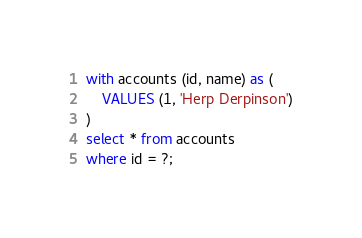Convert code to text. <code><loc_0><loc_0><loc_500><loc_500><_SQL_>with accounts (id, name) as (
    VALUES (1, 'Herp Derpinson')
)
select * from accounts
where id = ?;
</code> 